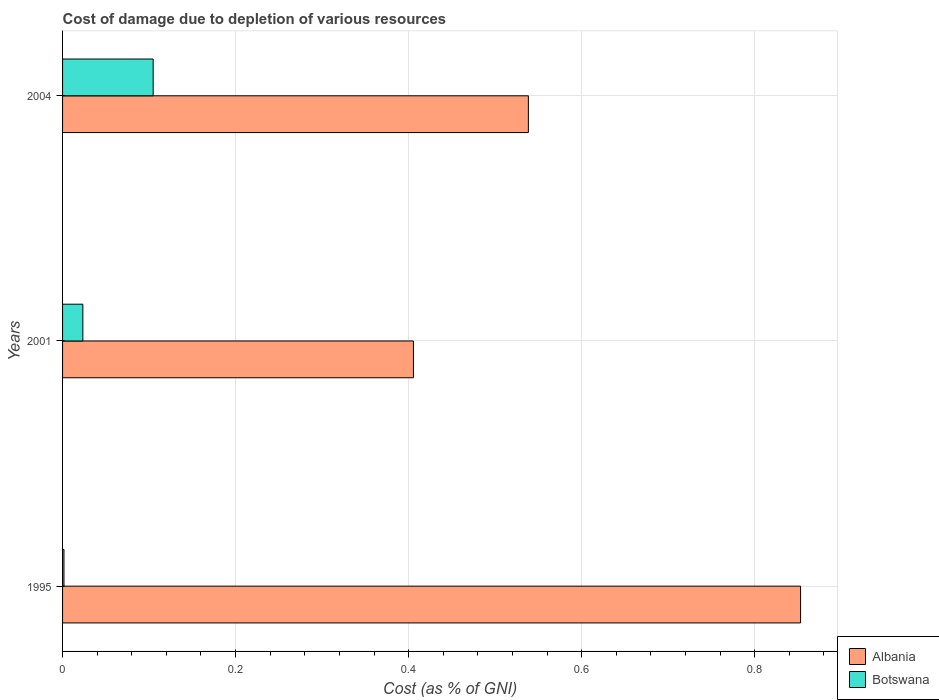How many groups of bars are there?
Offer a terse response. 3. How many bars are there on the 1st tick from the bottom?
Your answer should be very brief. 2. In how many cases, is the number of bars for a given year not equal to the number of legend labels?
Ensure brevity in your answer.  0. What is the cost of damage caused due to the depletion of various resources in Botswana in 2004?
Give a very brief answer. 0.1. Across all years, what is the maximum cost of damage caused due to the depletion of various resources in Botswana?
Give a very brief answer. 0.1. Across all years, what is the minimum cost of damage caused due to the depletion of various resources in Albania?
Your answer should be very brief. 0.41. What is the total cost of damage caused due to the depletion of various resources in Albania in the graph?
Your answer should be very brief. 1.8. What is the difference between the cost of damage caused due to the depletion of various resources in Botswana in 1995 and that in 2001?
Offer a terse response. -0.02. What is the difference between the cost of damage caused due to the depletion of various resources in Botswana in 2004 and the cost of damage caused due to the depletion of various resources in Albania in 2001?
Keep it short and to the point. -0.3. What is the average cost of damage caused due to the depletion of various resources in Botswana per year?
Make the answer very short. 0.04. In the year 1995, what is the difference between the cost of damage caused due to the depletion of various resources in Albania and cost of damage caused due to the depletion of various resources in Botswana?
Give a very brief answer. 0.85. What is the ratio of the cost of damage caused due to the depletion of various resources in Botswana in 2001 to that in 2004?
Keep it short and to the point. 0.22. Is the cost of damage caused due to the depletion of various resources in Botswana in 1995 less than that in 2004?
Offer a terse response. Yes. What is the difference between the highest and the second highest cost of damage caused due to the depletion of various resources in Albania?
Your response must be concise. 0.31. What is the difference between the highest and the lowest cost of damage caused due to the depletion of various resources in Botswana?
Offer a terse response. 0.1. In how many years, is the cost of damage caused due to the depletion of various resources in Albania greater than the average cost of damage caused due to the depletion of various resources in Albania taken over all years?
Your answer should be very brief. 1. What does the 1st bar from the top in 1995 represents?
Give a very brief answer. Botswana. What does the 2nd bar from the bottom in 2001 represents?
Keep it short and to the point. Botswana. How many years are there in the graph?
Offer a terse response. 3. How are the legend labels stacked?
Your answer should be very brief. Vertical. What is the title of the graph?
Keep it short and to the point. Cost of damage due to depletion of various resources. Does "Greece" appear as one of the legend labels in the graph?
Your answer should be very brief. No. What is the label or title of the X-axis?
Give a very brief answer. Cost (as % of GNI). What is the Cost (as % of GNI) of Albania in 1995?
Offer a very short reply. 0.85. What is the Cost (as % of GNI) of Botswana in 1995?
Give a very brief answer. 0. What is the Cost (as % of GNI) of Albania in 2001?
Make the answer very short. 0.41. What is the Cost (as % of GNI) of Botswana in 2001?
Give a very brief answer. 0.02. What is the Cost (as % of GNI) of Albania in 2004?
Offer a terse response. 0.54. What is the Cost (as % of GNI) of Botswana in 2004?
Your answer should be very brief. 0.1. Across all years, what is the maximum Cost (as % of GNI) in Albania?
Keep it short and to the point. 0.85. Across all years, what is the maximum Cost (as % of GNI) of Botswana?
Your answer should be compact. 0.1. Across all years, what is the minimum Cost (as % of GNI) of Albania?
Your response must be concise. 0.41. Across all years, what is the minimum Cost (as % of GNI) of Botswana?
Make the answer very short. 0. What is the total Cost (as % of GNI) of Albania in the graph?
Offer a very short reply. 1.8. What is the total Cost (as % of GNI) of Botswana in the graph?
Offer a very short reply. 0.13. What is the difference between the Cost (as % of GNI) of Albania in 1995 and that in 2001?
Provide a succinct answer. 0.45. What is the difference between the Cost (as % of GNI) of Botswana in 1995 and that in 2001?
Provide a short and direct response. -0.02. What is the difference between the Cost (as % of GNI) in Albania in 1995 and that in 2004?
Your answer should be compact. 0.31. What is the difference between the Cost (as % of GNI) in Botswana in 1995 and that in 2004?
Ensure brevity in your answer.  -0.1. What is the difference between the Cost (as % of GNI) in Albania in 2001 and that in 2004?
Your answer should be very brief. -0.13. What is the difference between the Cost (as % of GNI) of Botswana in 2001 and that in 2004?
Your response must be concise. -0.08. What is the difference between the Cost (as % of GNI) of Albania in 1995 and the Cost (as % of GNI) of Botswana in 2001?
Make the answer very short. 0.83. What is the difference between the Cost (as % of GNI) of Albania in 1995 and the Cost (as % of GNI) of Botswana in 2004?
Provide a short and direct response. 0.75. What is the difference between the Cost (as % of GNI) in Albania in 2001 and the Cost (as % of GNI) in Botswana in 2004?
Make the answer very short. 0.3. What is the average Cost (as % of GNI) in Albania per year?
Offer a very short reply. 0.6. What is the average Cost (as % of GNI) of Botswana per year?
Your answer should be very brief. 0.04. In the year 1995, what is the difference between the Cost (as % of GNI) of Albania and Cost (as % of GNI) of Botswana?
Ensure brevity in your answer.  0.85. In the year 2001, what is the difference between the Cost (as % of GNI) in Albania and Cost (as % of GNI) in Botswana?
Give a very brief answer. 0.38. In the year 2004, what is the difference between the Cost (as % of GNI) of Albania and Cost (as % of GNI) of Botswana?
Your answer should be very brief. 0.43. What is the ratio of the Cost (as % of GNI) of Albania in 1995 to that in 2001?
Keep it short and to the point. 2.1. What is the ratio of the Cost (as % of GNI) of Botswana in 1995 to that in 2001?
Your answer should be compact. 0.07. What is the ratio of the Cost (as % of GNI) in Albania in 1995 to that in 2004?
Your response must be concise. 1.58. What is the ratio of the Cost (as % of GNI) in Botswana in 1995 to that in 2004?
Give a very brief answer. 0.02. What is the ratio of the Cost (as % of GNI) of Albania in 2001 to that in 2004?
Your answer should be compact. 0.75. What is the ratio of the Cost (as % of GNI) in Botswana in 2001 to that in 2004?
Your response must be concise. 0.22. What is the difference between the highest and the second highest Cost (as % of GNI) in Albania?
Give a very brief answer. 0.31. What is the difference between the highest and the second highest Cost (as % of GNI) of Botswana?
Keep it short and to the point. 0.08. What is the difference between the highest and the lowest Cost (as % of GNI) in Albania?
Your answer should be compact. 0.45. What is the difference between the highest and the lowest Cost (as % of GNI) of Botswana?
Offer a very short reply. 0.1. 